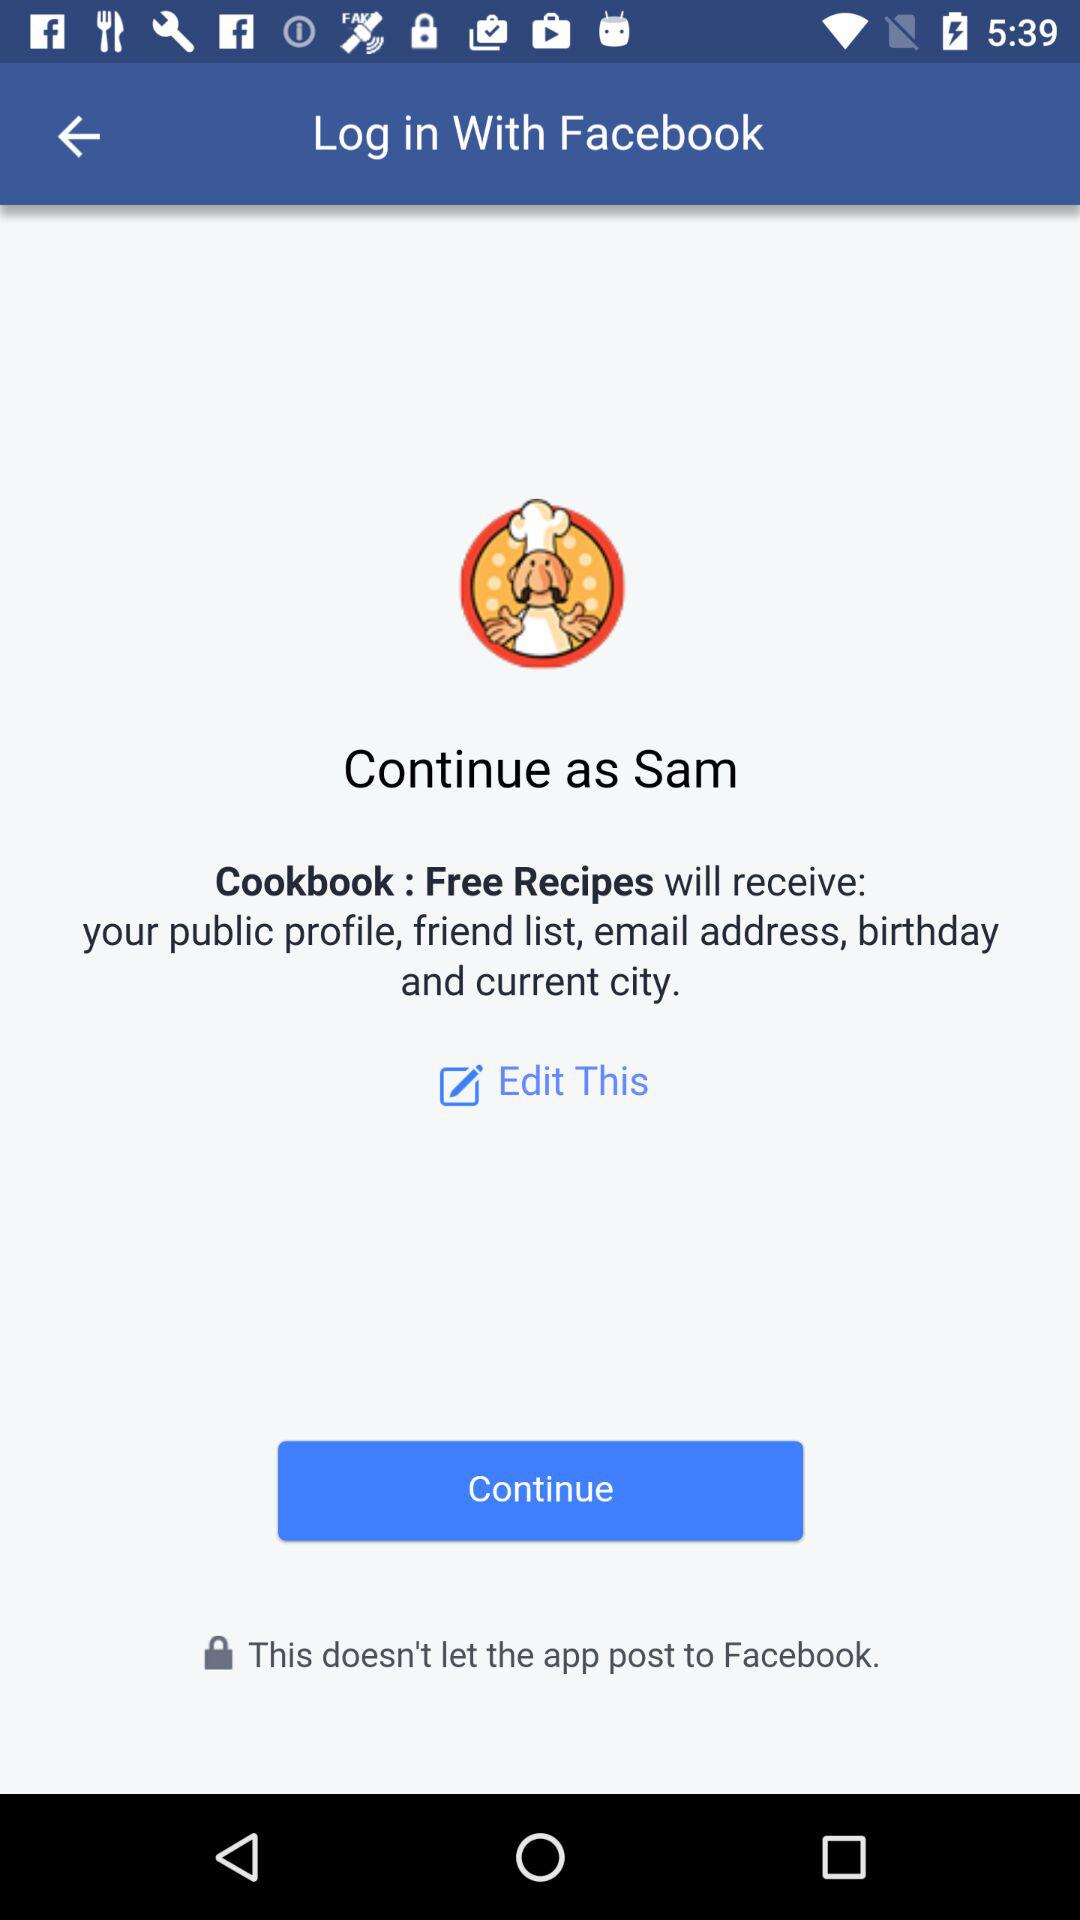What application is asking for permission? The application asking for permission is "Cookbook : Free Recipes". 